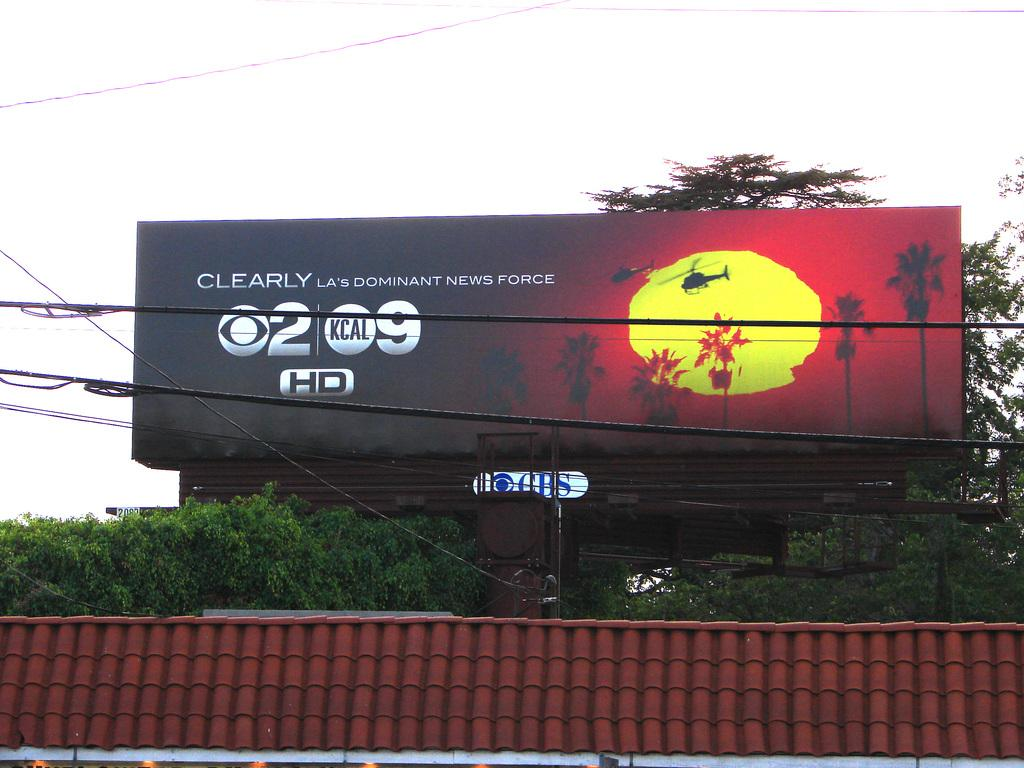<image>
Offer a succinct explanation of the picture presented. News force sign is on a banner outside on top of a building 